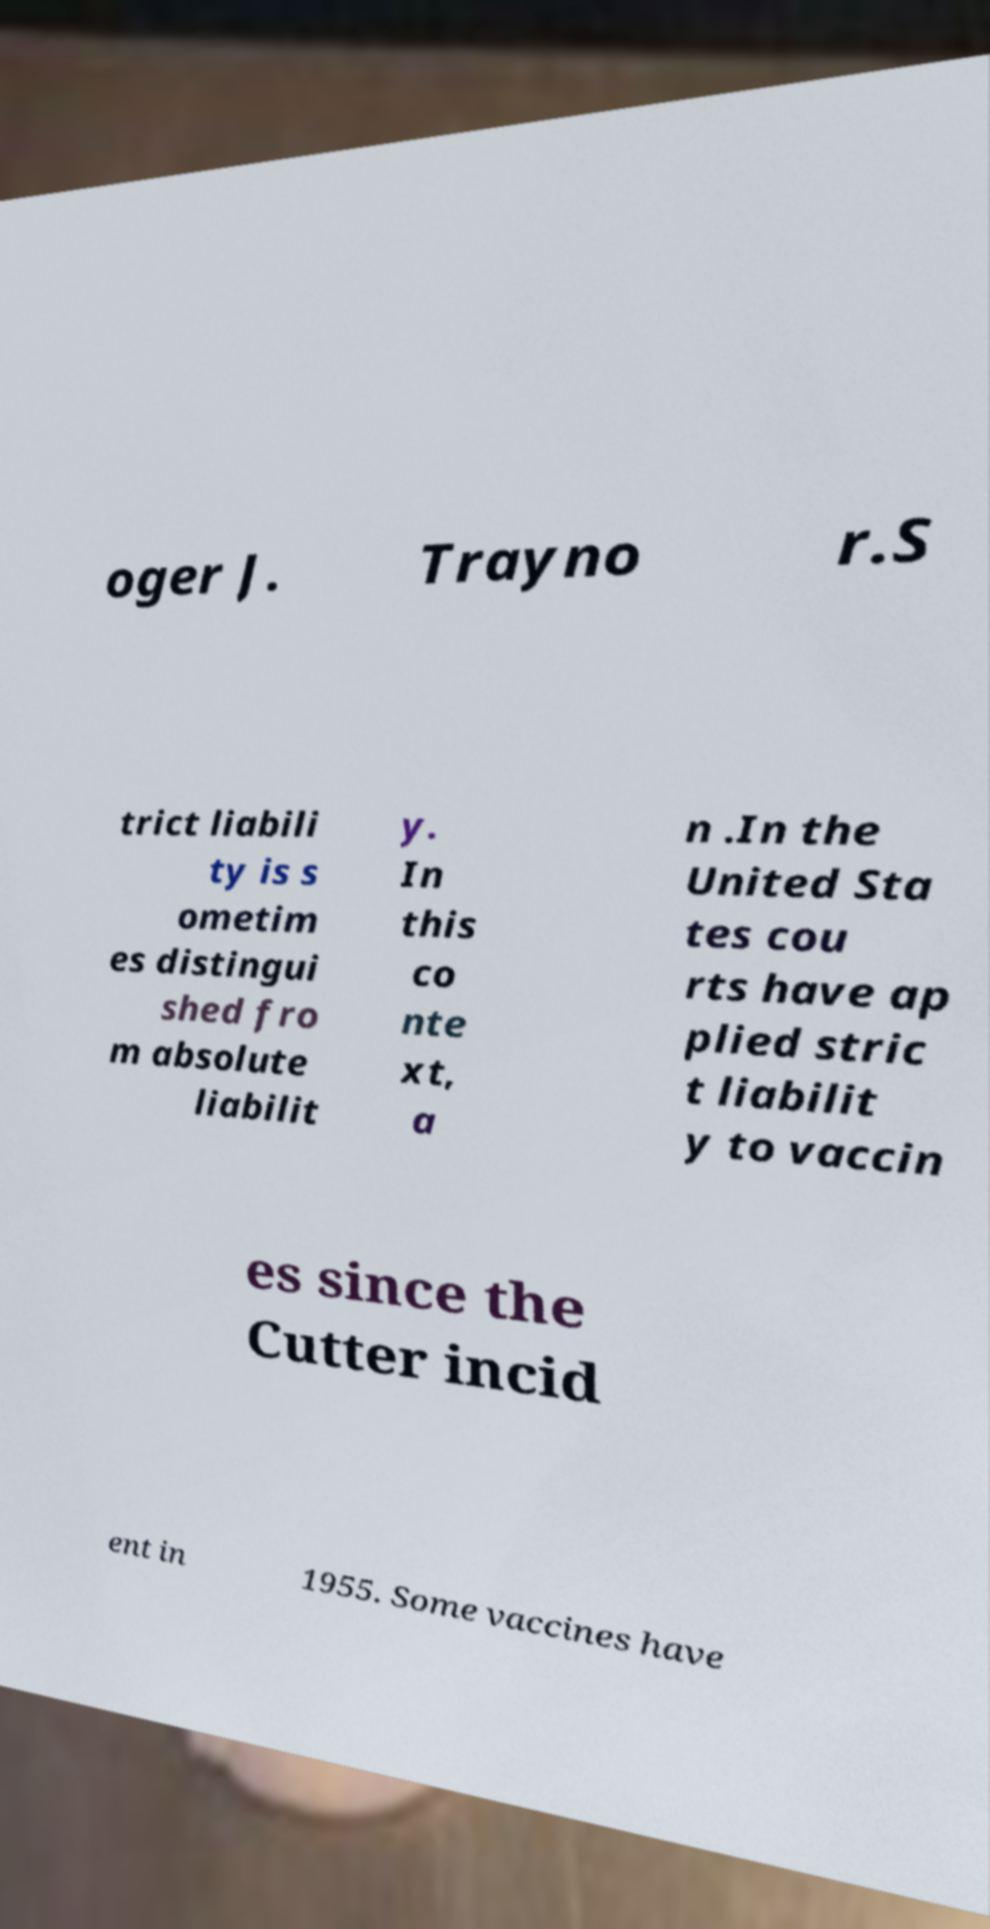Can you read and provide the text displayed in the image?This photo seems to have some interesting text. Can you extract and type it out for me? oger J. Trayno r.S trict liabili ty is s ometim es distingui shed fro m absolute liabilit y. In this co nte xt, a n .In the United Sta tes cou rts have ap plied stric t liabilit y to vaccin es since the Cutter incid ent in 1955. Some vaccines have 